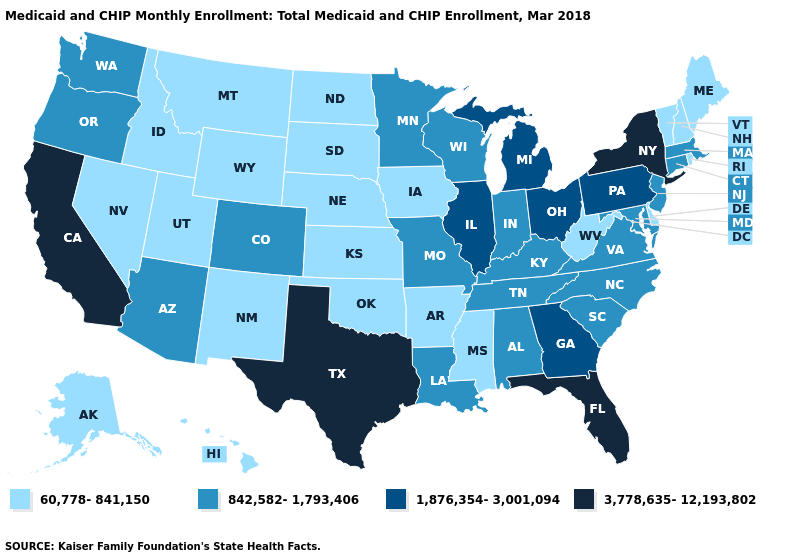Name the states that have a value in the range 842,582-1,793,406?
Keep it brief. Alabama, Arizona, Colorado, Connecticut, Indiana, Kentucky, Louisiana, Maryland, Massachusetts, Minnesota, Missouri, New Jersey, North Carolina, Oregon, South Carolina, Tennessee, Virginia, Washington, Wisconsin. Name the states that have a value in the range 3,778,635-12,193,802?
Answer briefly. California, Florida, New York, Texas. Name the states that have a value in the range 60,778-841,150?
Write a very short answer. Alaska, Arkansas, Delaware, Hawaii, Idaho, Iowa, Kansas, Maine, Mississippi, Montana, Nebraska, Nevada, New Hampshire, New Mexico, North Dakota, Oklahoma, Rhode Island, South Dakota, Utah, Vermont, West Virginia, Wyoming. What is the value of Texas?
Answer briefly. 3,778,635-12,193,802. Does New Jersey have the lowest value in the Northeast?
Write a very short answer. No. Name the states that have a value in the range 3,778,635-12,193,802?
Short answer required. California, Florida, New York, Texas. What is the value of Alaska?
Quick response, please. 60,778-841,150. Which states have the lowest value in the USA?
Write a very short answer. Alaska, Arkansas, Delaware, Hawaii, Idaho, Iowa, Kansas, Maine, Mississippi, Montana, Nebraska, Nevada, New Hampshire, New Mexico, North Dakota, Oklahoma, Rhode Island, South Dakota, Utah, Vermont, West Virginia, Wyoming. Among the states that border Ohio , does Kentucky have the highest value?
Answer briefly. No. Is the legend a continuous bar?
Write a very short answer. No. Name the states that have a value in the range 842,582-1,793,406?
Give a very brief answer. Alabama, Arizona, Colorado, Connecticut, Indiana, Kentucky, Louisiana, Maryland, Massachusetts, Minnesota, Missouri, New Jersey, North Carolina, Oregon, South Carolina, Tennessee, Virginia, Washington, Wisconsin. Is the legend a continuous bar?
Keep it brief. No. What is the value of Colorado?
Short answer required. 842,582-1,793,406. Name the states that have a value in the range 842,582-1,793,406?
Be succinct. Alabama, Arizona, Colorado, Connecticut, Indiana, Kentucky, Louisiana, Maryland, Massachusetts, Minnesota, Missouri, New Jersey, North Carolina, Oregon, South Carolina, Tennessee, Virginia, Washington, Wisconsin. What is the value of Georgia?
Be succinct. 1,876,354-3,001,094. 